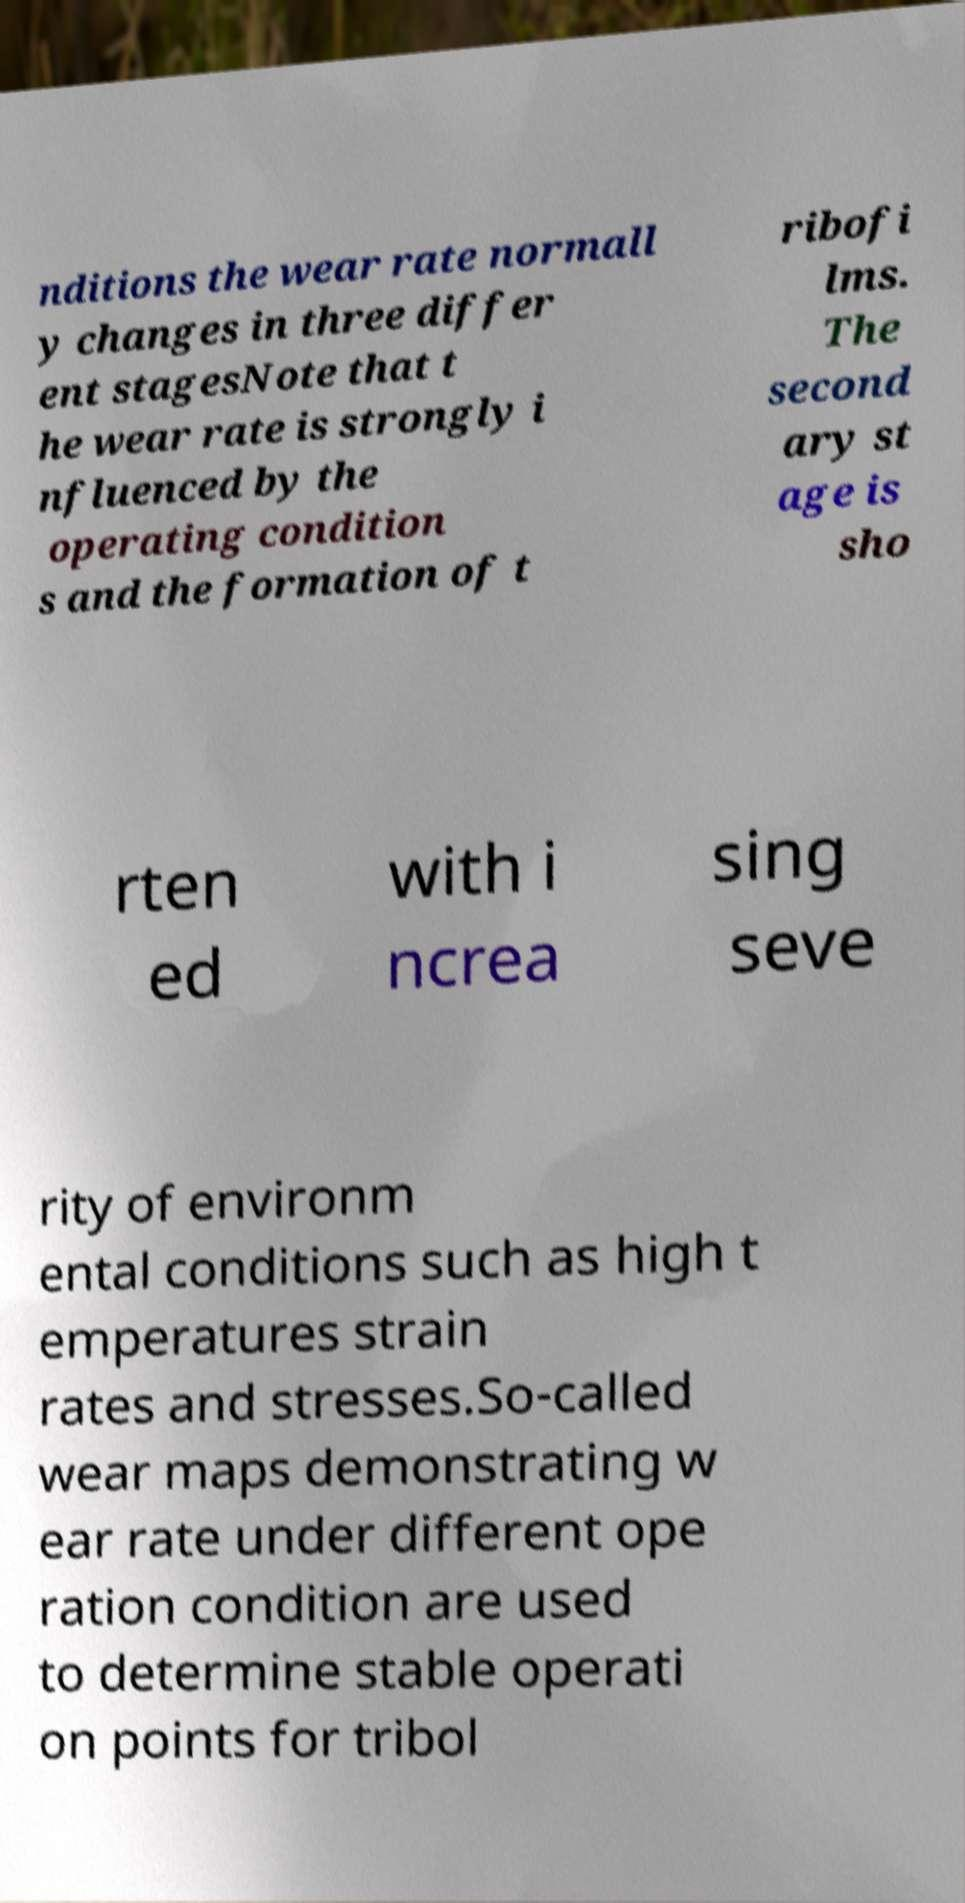Could you assist in decoding the text presented in this image and type it out clearly? nditions the wear rate normall y changes in three differ ent stagesNote that t he wear rate is strongly i nfluenced by the operating condition s and the formation of t ribofi lms. The second ary st age is sho rten ed with i ncrea sing seve rity of environm ental conditions such as high t emperatures strain rates and stresses.So-called wear maps demonstrating w ear rate under different ope ration condition are used to determine stable operati on points for tribol 